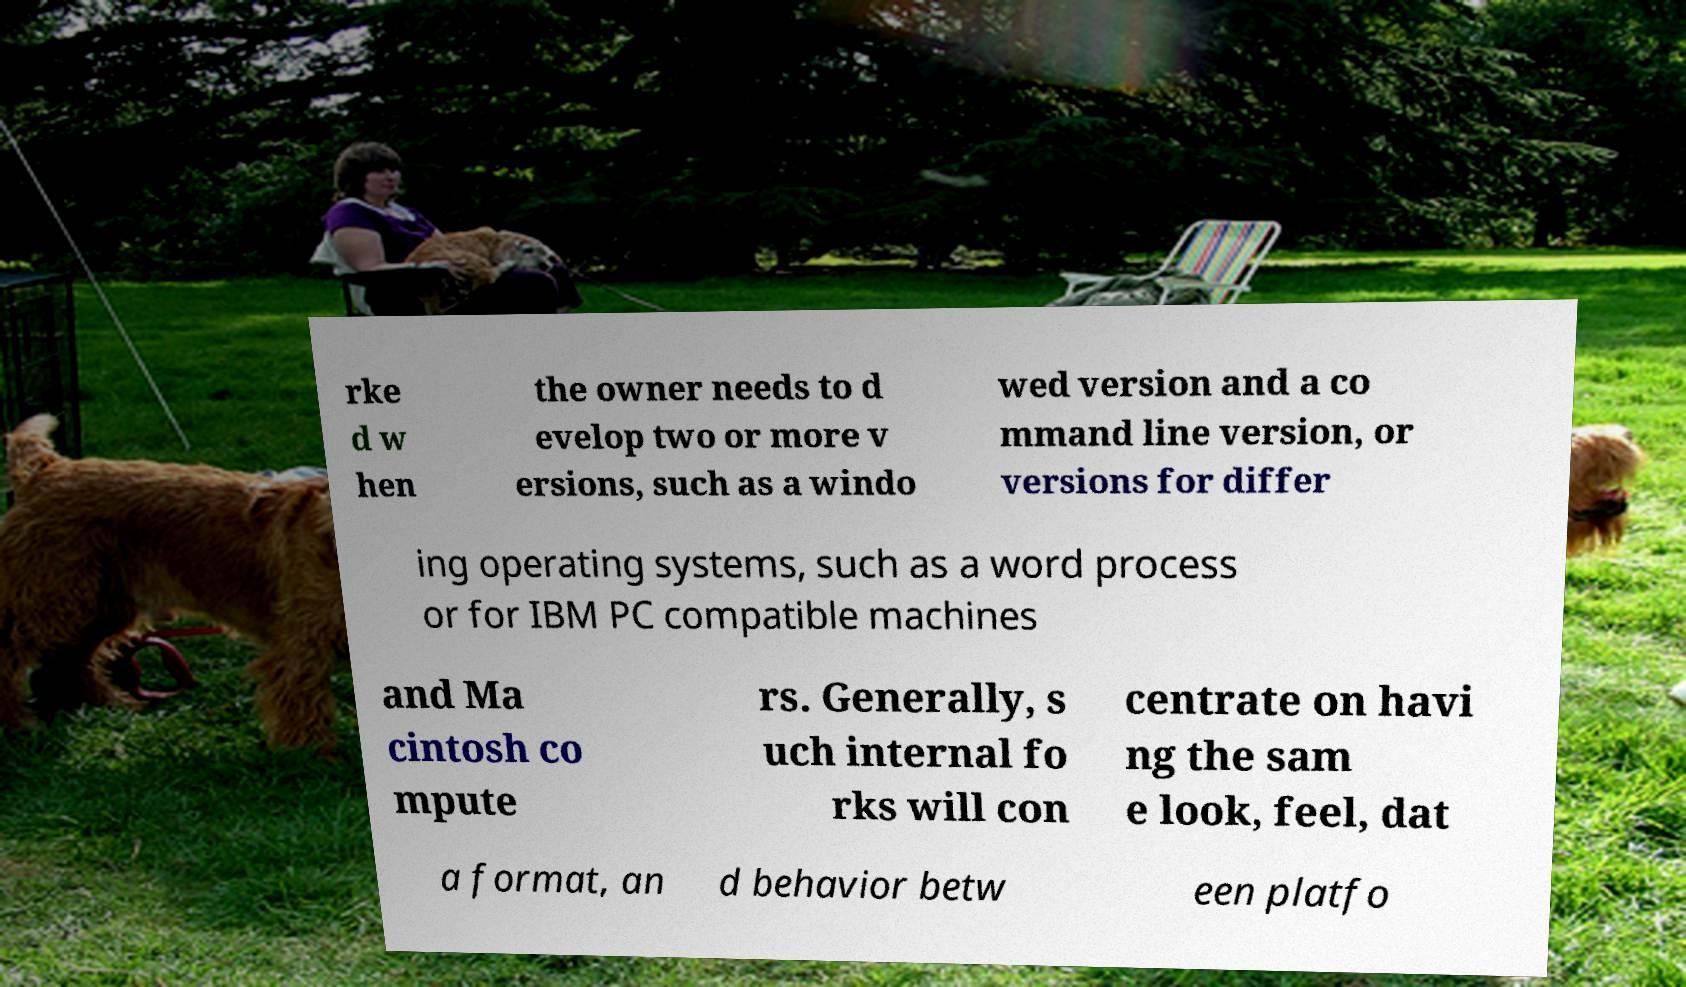Can you accurately transcribe the text from the provided image for me? rke d w hen the owner needs to d evelop two or more v ersions, such as a windo wed version and a co mmand line version, or versions for differ ing operating systems, such as a word process or for IBM PC compatible machines and Ma cintosh co mpute rs. Generally, s uch internal fo rks will con centrate on havi ng the sam e look, feel, dat a format, an d behavior betw een platfo 